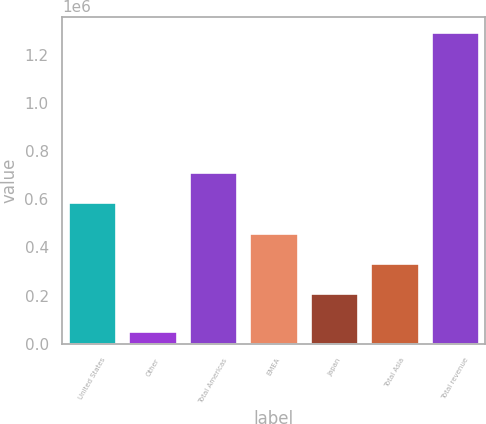Convert chart. <chart><loc_0><loc_0><loc_500><loc_500><bar_chart><fcel>United States<fcel>Other<fcel>Total Americas<fcel>EMEA<fcel>Japan<fcel>Total Asia<fcel>Total revenue<nl><fcel>588631<fcel>51551<fcel>712951<fcel>461145<fcel>212505<fcel>336825<fcel>1.29475e+06<nl></chart> 